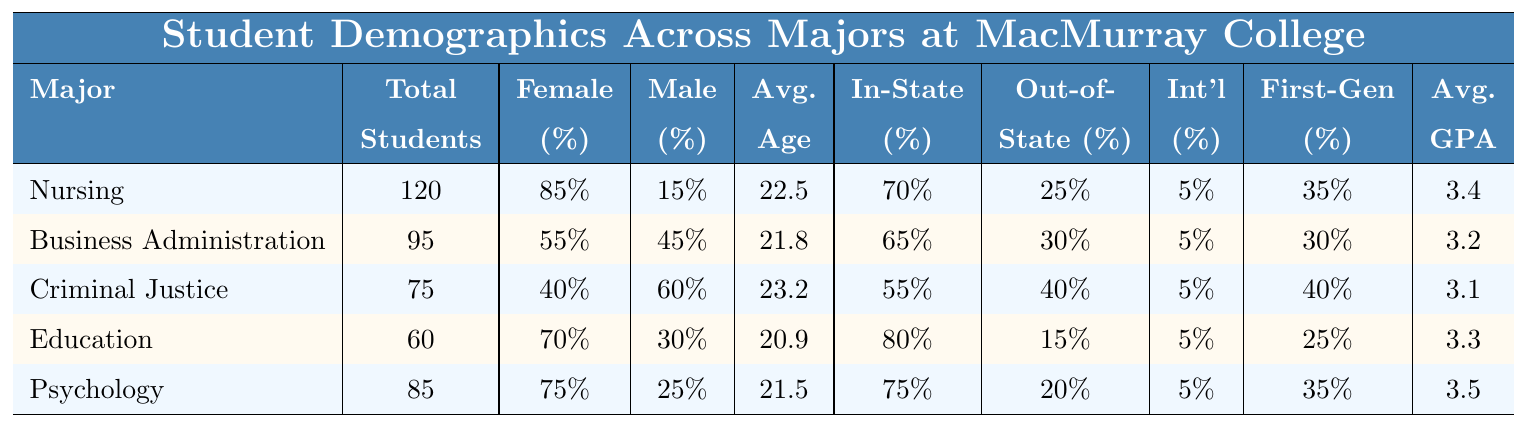What is the total number of students in the Nursing major? The table shows that the Nursing major has 120 total students listed under the "Total Students" column.
Answer: 120 What percentage of students in Business Administration are female? According to the table, 55% of the students in Business Administration are female, as indicated in the "Female" percentage column.
Answer: 55% Which major has the highest average GPA? By comparing the "Avg. GPA" column, Psychology has the highest average GPA of 3.5.
Answer: 3.5 What is the average age of students in Education? The table indicates that the average age for the Education major is 20.9 years, found in the "Avg. Age" column.
Answer: 20.9 Is the percentage of first-generation students in Criminal Justice greater than those in Business Administration? For Criminal Justice, the percentage of first-generation students is 40%, while for Business Administration it is 30%. Since 40% is greater than 30%, the statement is true.
Answer: Yes What is the difference in average age between Nursing and Criminal Justice majors? The average age for Nursing is 22.5 and for Criminal Justice is 23.2. To find the difference, subtract: 23.2 - 22.5 = 0.7.
Answer: 0.7 In which major is the percentage of international students the same as in the other majors? The table shows that all majors have 5% international students, thus, the percentage is the same across all majors.
Answer: All majors Which major has the highest percentage of in-state students? Looking at the "In-State %" column, Education has the highest at 80%.
Answer: Education What is the total number of students across all majors? To find the total, we sum the total students in each major: 120 + 95 + 75 + 60 + 85 = 435.
Answer: 435 Which major has the lowest percentage of male students? The lowest percentage of male students is in Nursing, where only 15% are male, as reflected in the "Male %" column.
Answer: Nursing What is the average percentage of out-of-state students across all majors? Adding the out-of-state percentages: 25 + 30 + 40 + 15 + 20 = 130. Divide by the number of majors (5): 130 / 5 = 26%.
Answer: 26% How many more total students are there in Psychology compared to Education? Psychology has 85 total students and Education has 60. Subtract: 85 - 60 = 25.
Answer: 25 Is the gender distribution in Nursing more skewed towards females than in Business Administration? In Nursing, 85% are female compared to 55% in Business Administration. Since 85% is greater, Nursing's distribution is more skewed towards females.
Answer: Yes What is the median percentage of female students across all majors? The percentages of female students are 85%, 55%, 40%, 70%, and 75%. Ordered, they are 40%, 55%, 70%, 75%, 85%. The median is the middle value, which is 70%.
Answer: 70% 